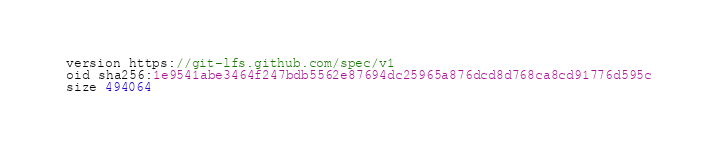<code> <loc_0><loc_0><loc_500><loc_500><_TypeScript_>version https://git-lfs.github.com/spec/v1
oid sha256:1e9541abe3464f247bdb5562e87694dc25965a876dcd8d768ca8cd91776d595c
size 494064
</code> 